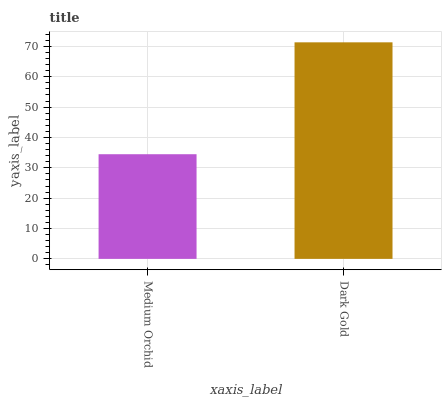Is Medium Orchid the minimum?
Answer yes or no. Yes. Is Dark Gold the maximum?
Answer yes or no. Yes. Is Dark Gold the minimum?
Answer yes or no. No. Is Dark Gold greater than Medium Orchid?
Answer yes or no. Yes. Is Medium Orchid less than Dark Gold?
Answer yes or no. Yes. Is Medium Orchid greater than Dark Gold?
Answer yes or no. No. Is Dark Gold less than Medium Orchid?
Answer yes or no. No. Is Dark Gold the high median?
Answer yes or no. Yes. Is Medium Orchid the low median?
Answer yes or no. Yes. Is Medium Orchid the high median?
Answer yes or no. No. Is Dark Gold the low median?
Answer yes or no. No. 